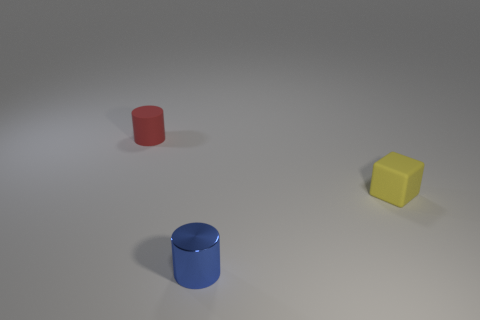There is a small rubber object that is to the right of the metal cylinder; what is its color?
Your response must be concise. Yellow. Is there any other thing that has the same color as the matte block?
Offer a terse response. No. Do the blue object and the matte block have the same size?
Make the answer very short. Yes. How many cylinders are the same material as the tiny red object?
Ensure brevity in your answer.  0. The small metal thing has what color?
Make the answer very short. Blue. There is a matte object that is to the right of the blue cylinder; does it have the same shape as the blue object?
Provide a short and direct response. No. What number of things are tiny cylinders that are to the left of the blue thing or small blue metallic cylinders?
Ensure brevity in your answer.  2. Is there a small blue object of the same shape as the small red rubber thing?
Offer a very short reply. Yes. The blue object that is the same size as the red cylinder is what shape?
Your answer should be compact. Cylinder. What is the shape of the tiny metal thing that is in front of the tiny matte object on the right side of the tiny cylinder that is in front of the small red object?
Give a very brief answer. Cylinder. 